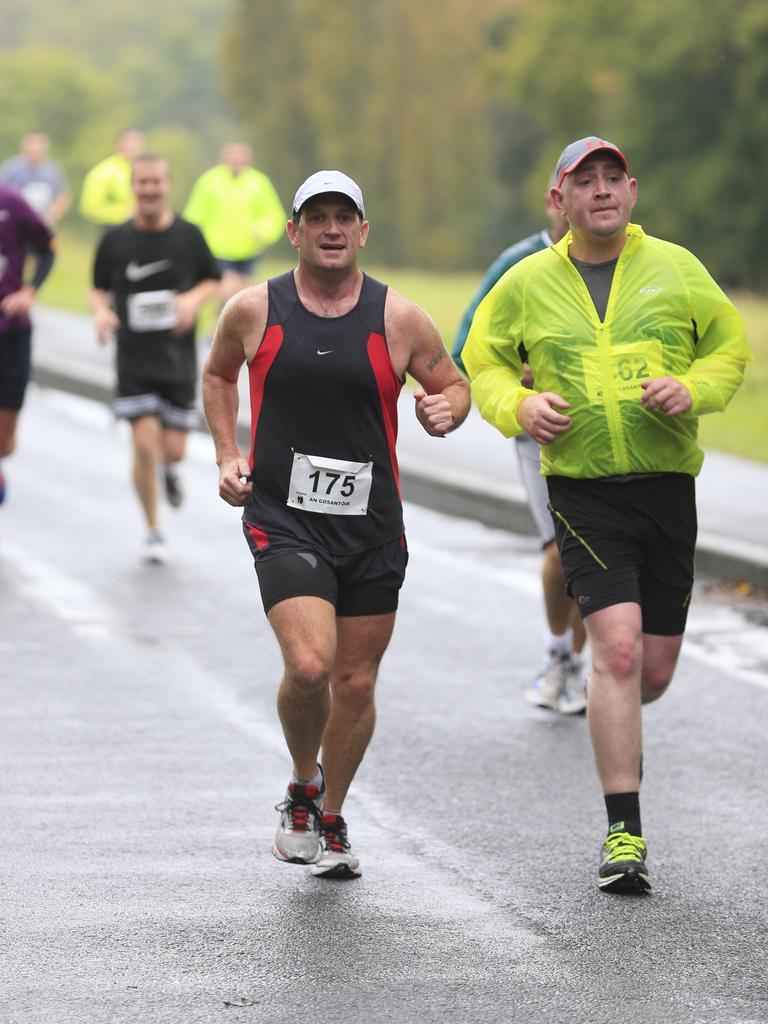Describe this image in one or two sentences. In this picture we can see some people are running, two persons in the front are wearing caps, in the background there are some trees and grass. 